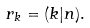Convert formula to latex. <formula><loc_0><loc_0><loc_500><loc_500>r _ { k } = ( k | n ) .</formula> 